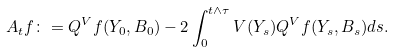Convert formula to latex. <formula><loc_0><loc_0><loc_500><loc_500>A _ { t } f \colon = Q ^ { V } f ( Y _ { 0 } , B _ { 0 } ) - 2 \int _ { 0 } ^ { t \wedge \tau } V ( Y _ { s } ) Q ^ { V } f ( Y _ { s } , B _ { s } ) d s .</formula> 